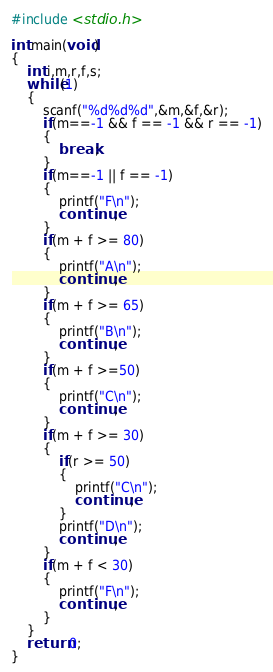<code> <loc_0><loc_0><loc_500><loc_500><_C_>#include <stdio.h>

int main(void)
{
	int i,m,r,f,s;
	while(1)
	{
		scanf("%d%d%d",&m,&f,&r);
		if(m==-1 && f == -1 && r == -1)
		{
			break;
		}
		if(m==-1 || f == -1)
		{
			printf("F\n");
			continue;
		}
		if(m + f >= 80)
		{
			printf("A\n");
			continue;
		}
		if(m + f >= 65)
		{
			printf("B\n");
			continue;
		}
		if(m + f >=50)
		{
			printf("C\n");
			continue;
		}
		if(m + f >= 30)
		{
			if(r >= 50)
			{
				printf("C\n");
				continue;
			}
			printf("D\n");
			continue;
		}
		if(m + f < 30)
		{
			printf("F\n");
			continue;
		}
	}
	return 0;
}</code> 